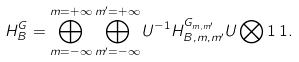Convert formula to latex. <formula><loc_0><loc_0><loc_500><loc_500>H ^ { G } _ { B } = \bigoplus _ { m = { - \infty } } ^ { m = + \infty } \bigoplus _ { m ^ { \prime } = { - \infty } } ^ { m ^ { \prime } = + \infty } U ^ { - 1 } H ^ { G _ { m , m ^ { \prime } } } _ { B , m , m ^ { \prime } } U \bigotimes 1 \, 1 .</formula> 